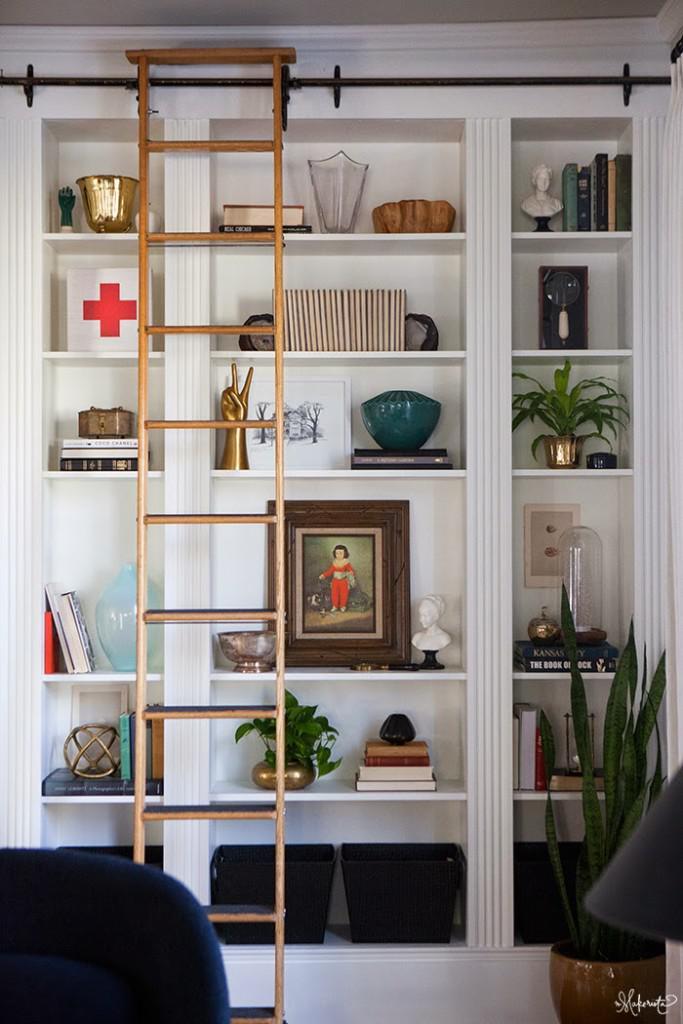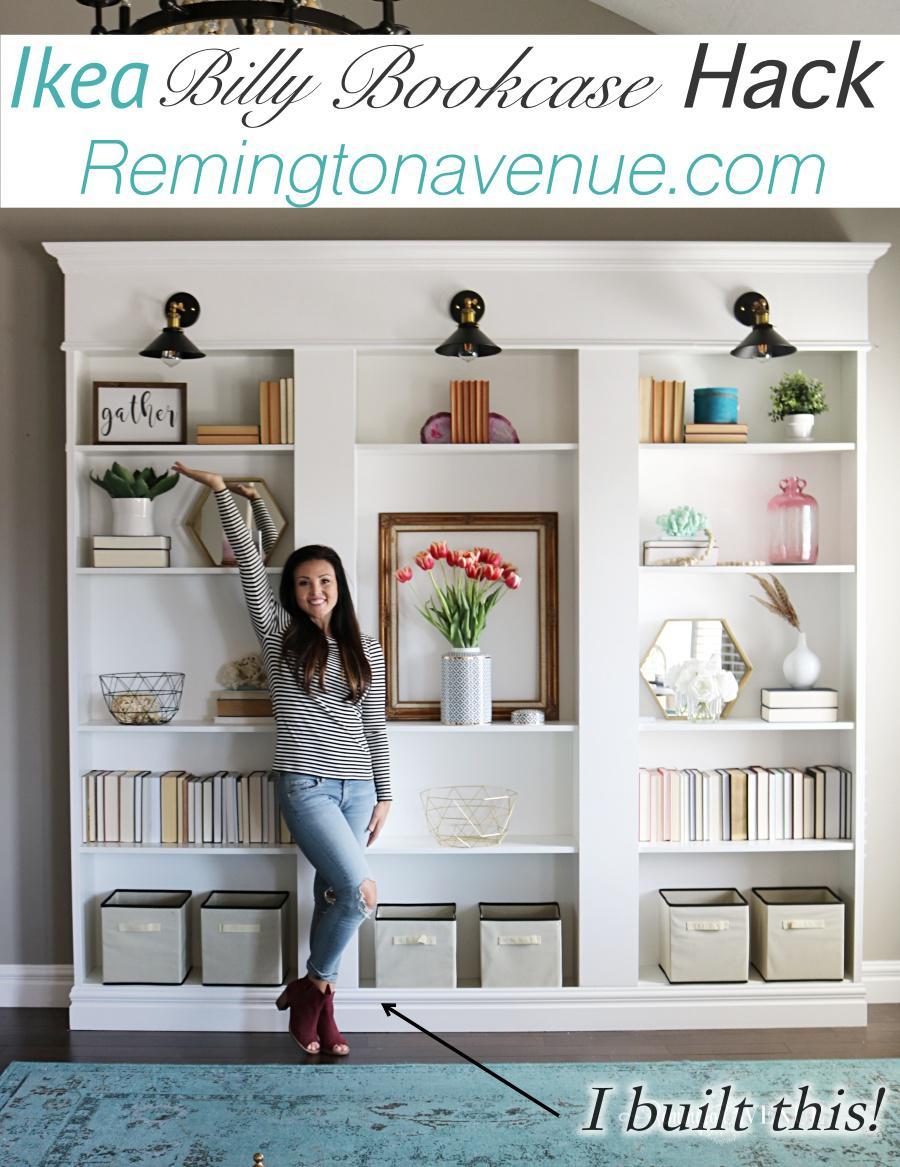The first image is the image on the left, the second image is the image on the right. Analyze the images presented: Is the assertion "An image features a woman in jeans in front of a white bookcase." valid? Answer yes or no. Yes. The first image is the image on the left, the second image is the image on the right. For the images shown, is this caption "The white bookshelves in one image are floor to ceiling and have a sliding ladder with visible track to allow access to upper shelves." true? Answer yes or no. Yes. 